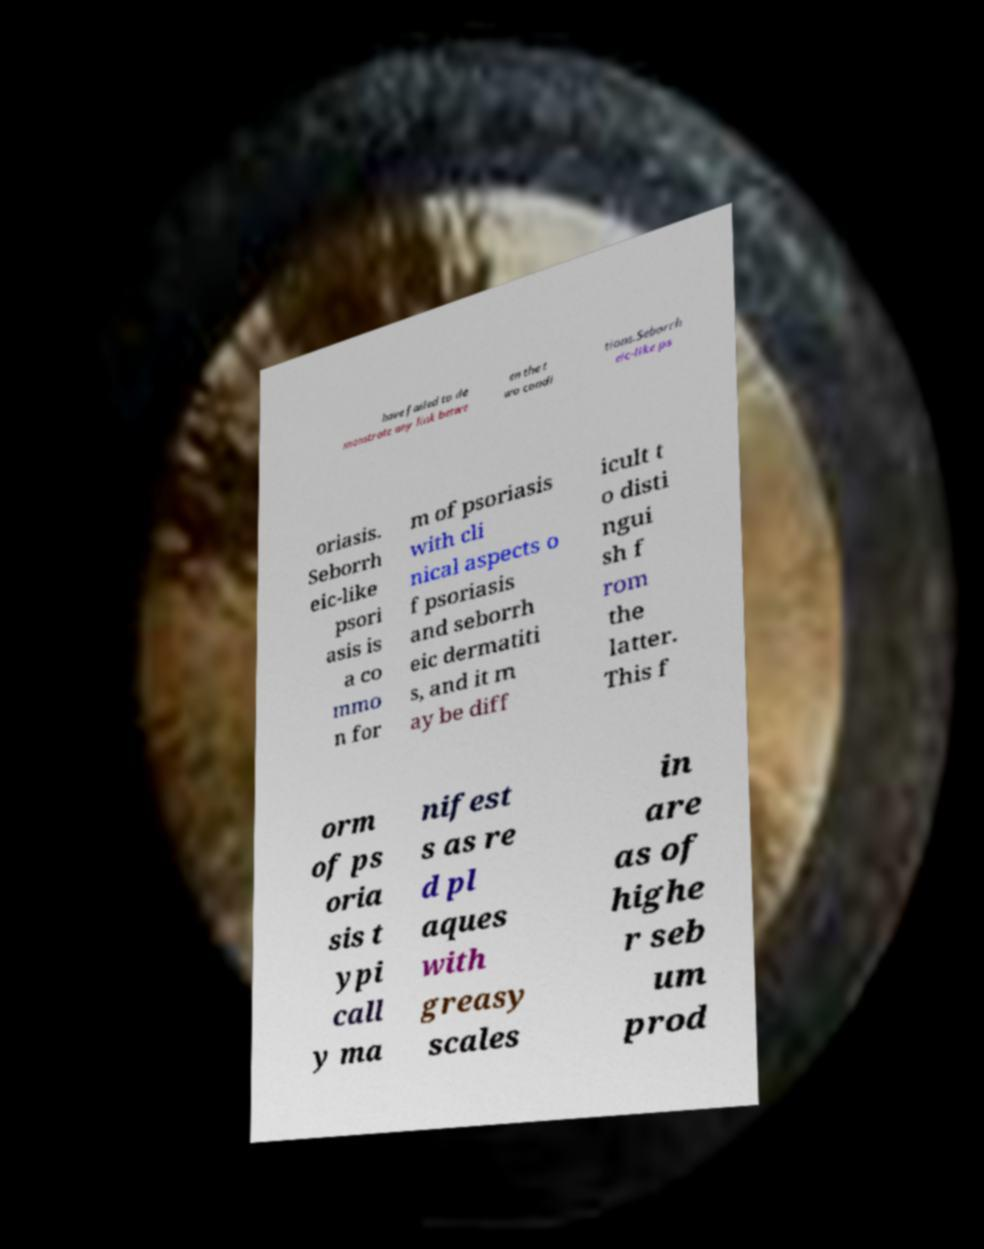There's text embedded in this image that I need extracted. Can you transcribe it verbatim? have failed to de monstrate any link betwe en the t wo condi tions.Seborrh eic-like ps oriasis. Seborrh eic-like psori asis is a co mmo n for m of psoriasis with cli nical aspects o f psoriasis and seborrh eic dermatiti s, and it m ay be diff icult t o disti ngui sh f rom the latter. This f orm of ps oria sis t ypi call y ma nifest s as re d pl aques with greasy scales in are as of highe r seb um prod 